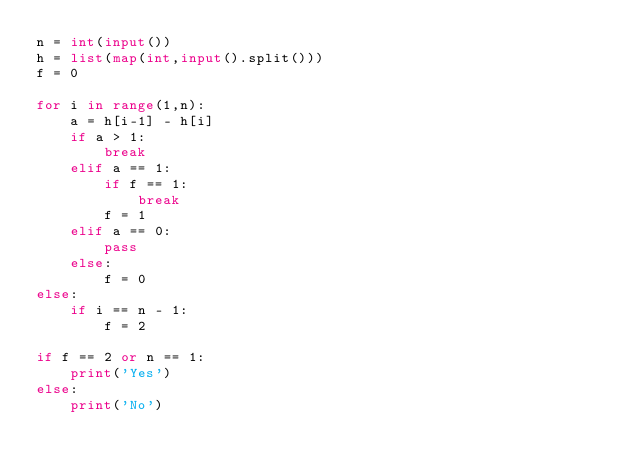Convert code to text. <code><loc_0><loc_0><loc_500><loc_500><_Python_>n = int(input())
h = list(map(int,input().split()))
f = 0

for i in range(1,n):
    a = h[i-1] - h[i]
    if a > 1:
        break
    elif a == 1:
        if f == 1:
            break
        f = 1
    elif a == 0:
        pass
    else:
        f = 0
else:
    if i == n - 1:
        f = 2

if f == 2 or n == 1:
    print('Yes')
else:
    print('No')</code> 